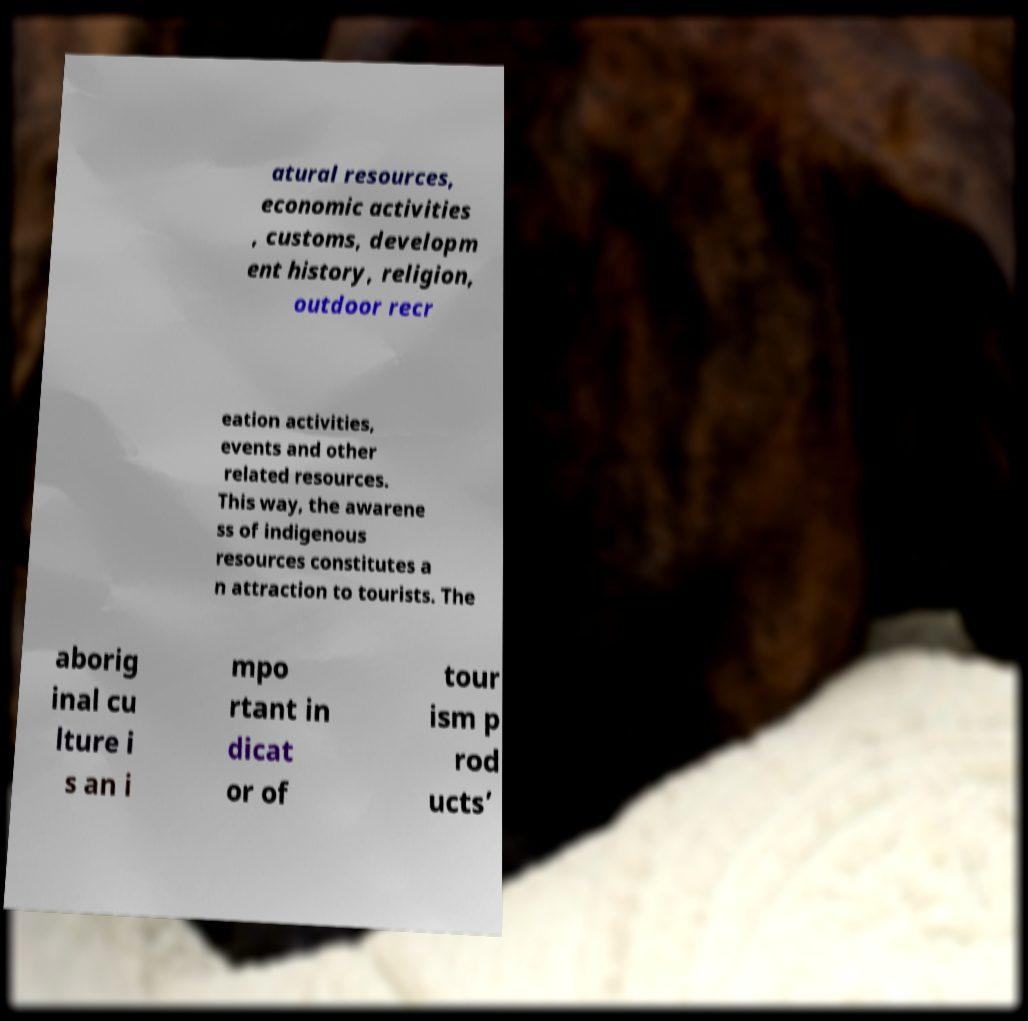Can you read and provide the text displayed in the image?This photo seems to have some interesting text. Can you extract and type it out for me? atural resources, economic activities , customs, developm ent history, religion, outdoor recr eation activities, events and other related resources. This way, the awarene ss of indigenous resources constitutes a n attraction to tourists. The aborig inal cu lture i s an i mpo rtant in dicat or of tour ism p rod ucts’ 